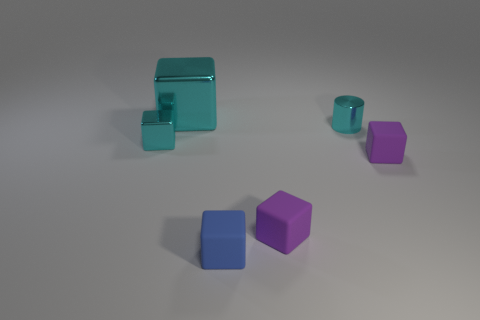Subtract all blue cubes. How many cubes are left? 4 Subtract all small blue blocks. How many blocks are left? 4 Subtract all green cubes. Subtract all blue spheres. How many cubes are left? 5 Subtract all cubes. How many objects are left? 1 Add 3 cyan metallic things. How many objects exist? 9 Subtract all purple blocks. Subtract all blue blocks. How many objects are left? 3 Add 3 blue matte objects. How many blue matte objects are left? 4 Add 6 small blue matte blocks. How many small blue matte blocks exist? 7 Subtract 0 red balls. How many objects are left? 6 